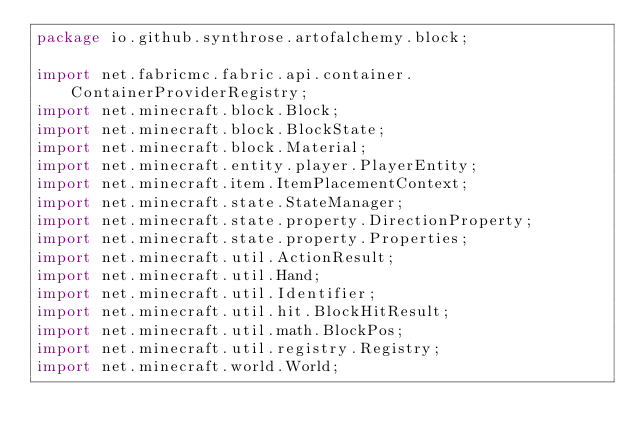Convert code to text. <code><loc_0><loc_0><loc_500><loc_500><_Java_>package io.github.synthrose.artofalchemy.block;

import net.fabricmc.fabric.api.container.ContainerProviderRegistry;
import net.minecraft.block.Block;
import net.minecraft.block.BlockState;
import net.minecraft.block.Material;
import net.minecraft.entity.player.PlayerEntity;
import net.minecraft.item.ItemPlacementContext;
import net.minecraft.state.StateManager;
import net.minecraft.state.property.DirectionProperty;
import net.minecraft.state.property.Properties;
import net.minecraft.util.ActionResult;
import net.minecraft.util.Hand;
import net.minecraft.util.Identifier;
import net.minecraft.util.hit.BlockHitResult;
import net.minecraft.util.math.BlockPos;
import net.minecraft.util.registry.Registry;
import net.minecraft.world.World;
</code> 